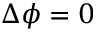Convert formula to latex. <formula><loc_0><loc_0><loc_500><loc_500>\Delta \phi = 0</formula> 